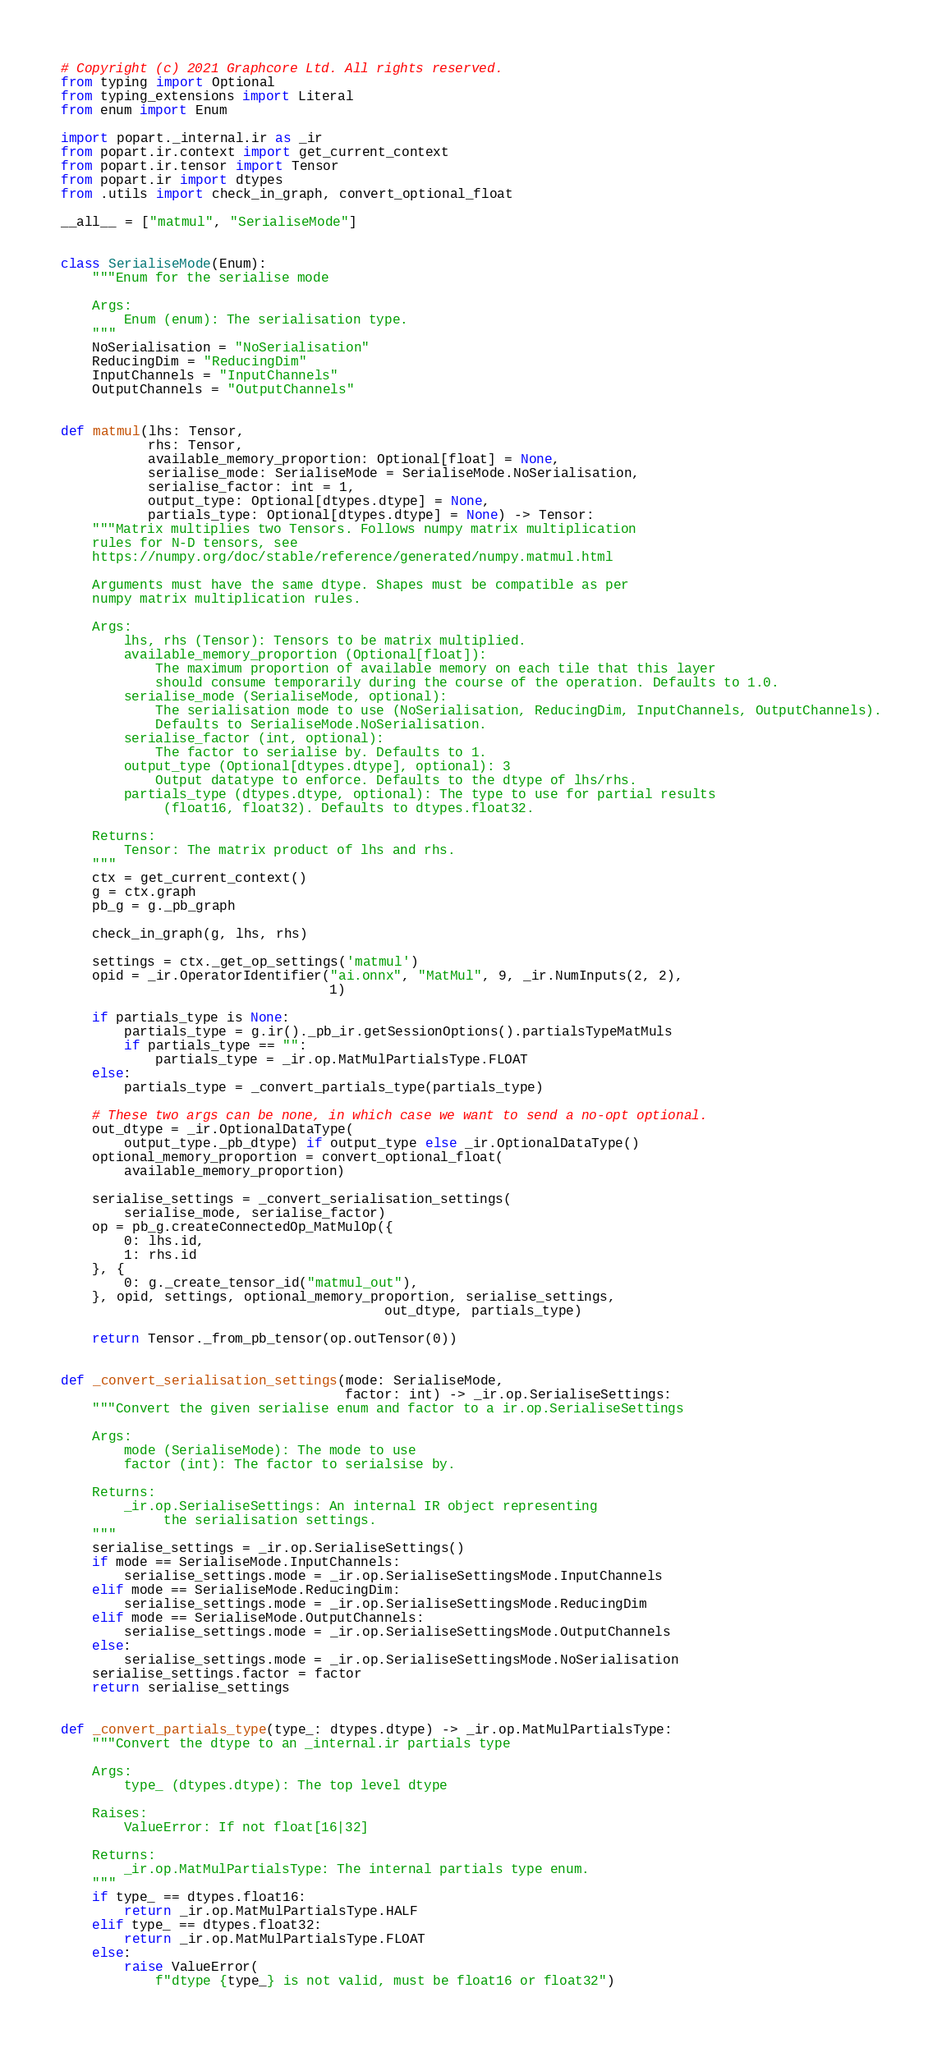Convert code to text. <code><loc_0><loc_0><loc_500><loc_500><_Python_># Copyright (c) 2021 Graphcore Ltd. All rights reserved.
from typing import Optional
from typing_extensions import Literal
from enum import Enum

import popart._internal.ir as _ir
from popart.ir.context import get_current_context
from popart.ir.tensor import Tensor
from popart.ir import dtypes
from .utils import check_in_graph, convert_optional_float

__all__ = ["matmul", "SerialiseMode"]


class SerialiseMode(Enum):
    """Enum for the serialise mode

    Args:
        Enum (enum): The serialisation type.
    """
    NoSerialisation = "NoSerialisation"
    ReducingDim = "ReducingDim"
    InputChannels = "InputChannels"
    OutputChannels = "OutputChannels"


def matmul(lhs: Tensor,
           rhs: Tensor,
           available_memory_proportion: Optional[float] = None,
           serialise_mode: SerialiseMode = SerialiseMode.NoSerialisation,
           serialise_factor: int = 1,
           output_type: Optional[dtypes.dtype] = None,
           partials_type: Optional[dtypes.dtype] = None) -> Tensor:
    """Matrix multiplies two Tensors. Follows numpy matrix multiplication
    rules for N-D tensors, see
    https://numpy.org/doc/stable/reference/generated/numpy.matmul.html

    Arguments must have the same dtype. Shapes must be compatible as per
    numpy matrix multiplication rules.

    Args:
        lhs, rhs (Tensor): Tensors to be matrix multiplied.
        available_memory_proportion (Optional[float]):
            The maximum proportion of available memory on each tile that this layer
            should consume temporarily during the course of the operation. Defaults to 1.0.
        serialise_mode (SerialiseMode, optional): 
            The serialisation mode to use (NoSerialisation, ReducingDim, InputChannels, OutputChannels).
            Defaults to SerialiseMode.NoSerialisation.
        serialise_factor (int, optional): 
            The factor to serialise by. Defaults to 1.
        output_type (Optional[dtypes.dtype], optional): 3
            Output datatype to enforce. Defaults to the dtype of lhs/rhs.
        partials_type (dtypes.dtype, optional): The type to use for partial results
             (float16, float32). Defaults to dtypes.float32.

    Returns:
        Tensor: The matrix product of lhs and rhs.
    """
    ctx = get_current_context()
    g = ctx.graph
    pb_g = g._pb_graph

    check_in_graph(g, lhs, rhs)

    settings = ctx._get_op_settings('matmul')
    opid = _ir.OperatorIdentifier("ai.onnx", "MatMul", 9, _ir.NumInputs(2, 2),
                                  1)

    if partials_type is None:
        partials_type = g.ir()._pb_ir.getSessionOptions().partialsTypeMatMuls
        if partials_type == "":
            partials_type = _ir.op.MatMulPartialsType.FLOAT
    else:
        partials_type = _convert_partials_type(partials_type)

    # These two args can be none, in which case we want to send a no-opt optional.
    out_dtype = _ir.OptionalDataType(
        output_type._pb_dtype) if output_type else _ir.OptionalDataType()
    optional_memory_proportion = convert_optional_float(
        available_memory_proportion)

    serialise_settings = _convert_serialisation_settings(
        serialise_mode, serialise_factor)
    op = pb_g.createConnectedOp_MatMulOp({
        0: lhs.id,
        1: rhs.id
    }, {
        0: g._create_tensor_id("matmul_out"),
    }, opid, settings, optional_memory_proportion, serialise_settings,
                                         out_dtype, partials_type)

    return Tensor._from_pb_tensor(op.outTensor(0))


def _convert_serialisation_settings(mode: SerialiseMode,
                                    factor: int) -> _ir.op.SerialiseSettings:
    """Convert the given serialise enum and factor to a ir.op.SerialiseSettings

    Args:
        mode (SerialiseMode): The mode to use
        factor (int): The factor to serialsise by.

    Returns:
        _ir.op.SerialiseSettings: An internal IR object representing
             the serialisation settings.
    """
    serialise_settings = _ir.op.SerialiseSettings()
    if mode == SerialiseMode.InputChannels:
        serialise_settings.mode = _ir.op.SerialiseSettingsMode.InputChannels
    elif mode == SerialiseMode.ReducingDim:
        serialise_settings.mode = _ir.op.SerialiseSettingsMode.ReducingDim
    elif mode == SerialiseMode.OutputChannels:
        serialise_settings.mode = _ir.op.SerialiseSettingsMode.OutputChannels
    else:
        serialise_settings.mode = _ir.op.SerialiseSettingsMode.NoSerialisation
    serialise_settings.factor = factor
    return serialise_settings


def _convert_partials_type(type_: dtypes.dtype) -> _ir.op.MatMulPartialsType:
    """Convert the dtype to an _internal.ir partials type

    Args:
        type_ (dtypes.dtype): The top level dtype

    Raises:
        ValueError: If not float[16|32]

    Returns:
        _ir.op.MatMulPartialsType: The internal partials type enum.
    """
    if type_ == dtypes.float16:
        return _ir.op.MatMulPartialsType.HALF
    elif type_ == dtypes.float32:
        return _ir.op.MatMulPartialsType.FLOAT
    else:
        raise ValueError(
            f"dtype {type_} is not valid, must be float16 or float32")
</code> 